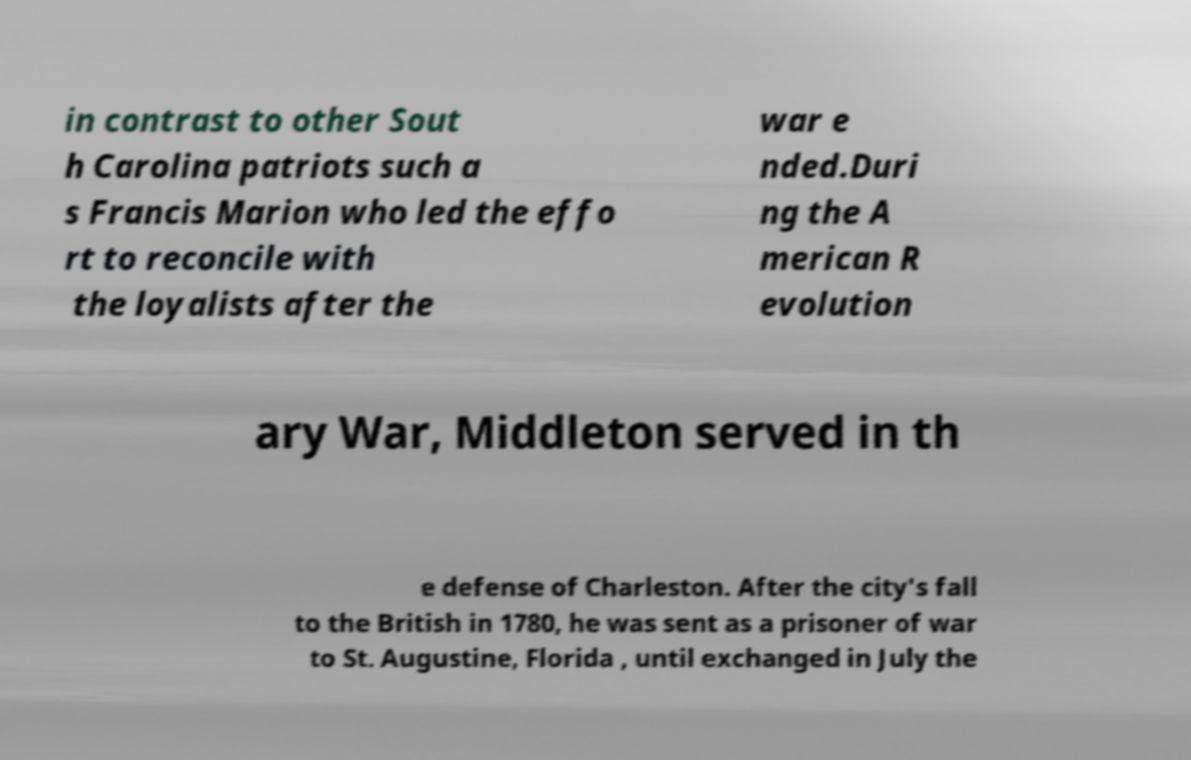Can you accurately transcribe the text from the provided image for me? in contrast to other Sout h Carolina patriots such a s Francis Marion who led the effo rt to reconcile with the loyalists after the war e nded.Duri ng the A merican R evolution ary War, Middleton served in th e defense of Charleston. After the city's fall to the British in 1780, he was sent as a prisoner of war to St. Augustine, Florida , until exchanged in July the 